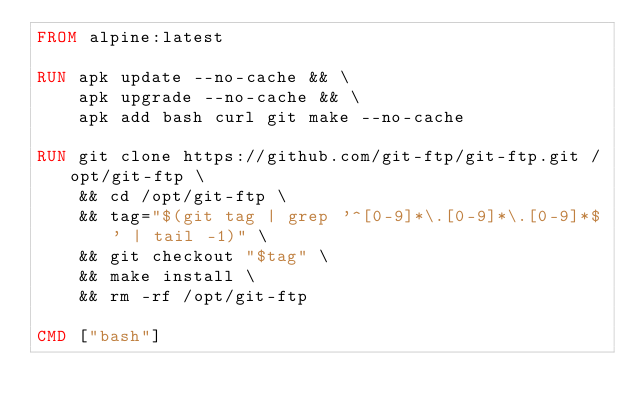<code> <loc_0><loc_0><loc_500><loc_500><_Dockerfile_>FROM alpine:latest

RUN apk update --no-cache && \
    apk upgrade --no-cache && \
    apk add bash curl git make --no-cache

RUN git clone https://github.com/git-ftp/git-ftp.git /opt/git-ftp \
    && cd /opt/git-ftp \
    && tag="$(git tag | grep '^[0-9]*\.[0-9]*\.[0-9]*$' | tail -1)" \
    && git checkout "$tag" \
    && make install \
    && rm -rf /opt/git-ftp

CMD ["bash"]
</code> 